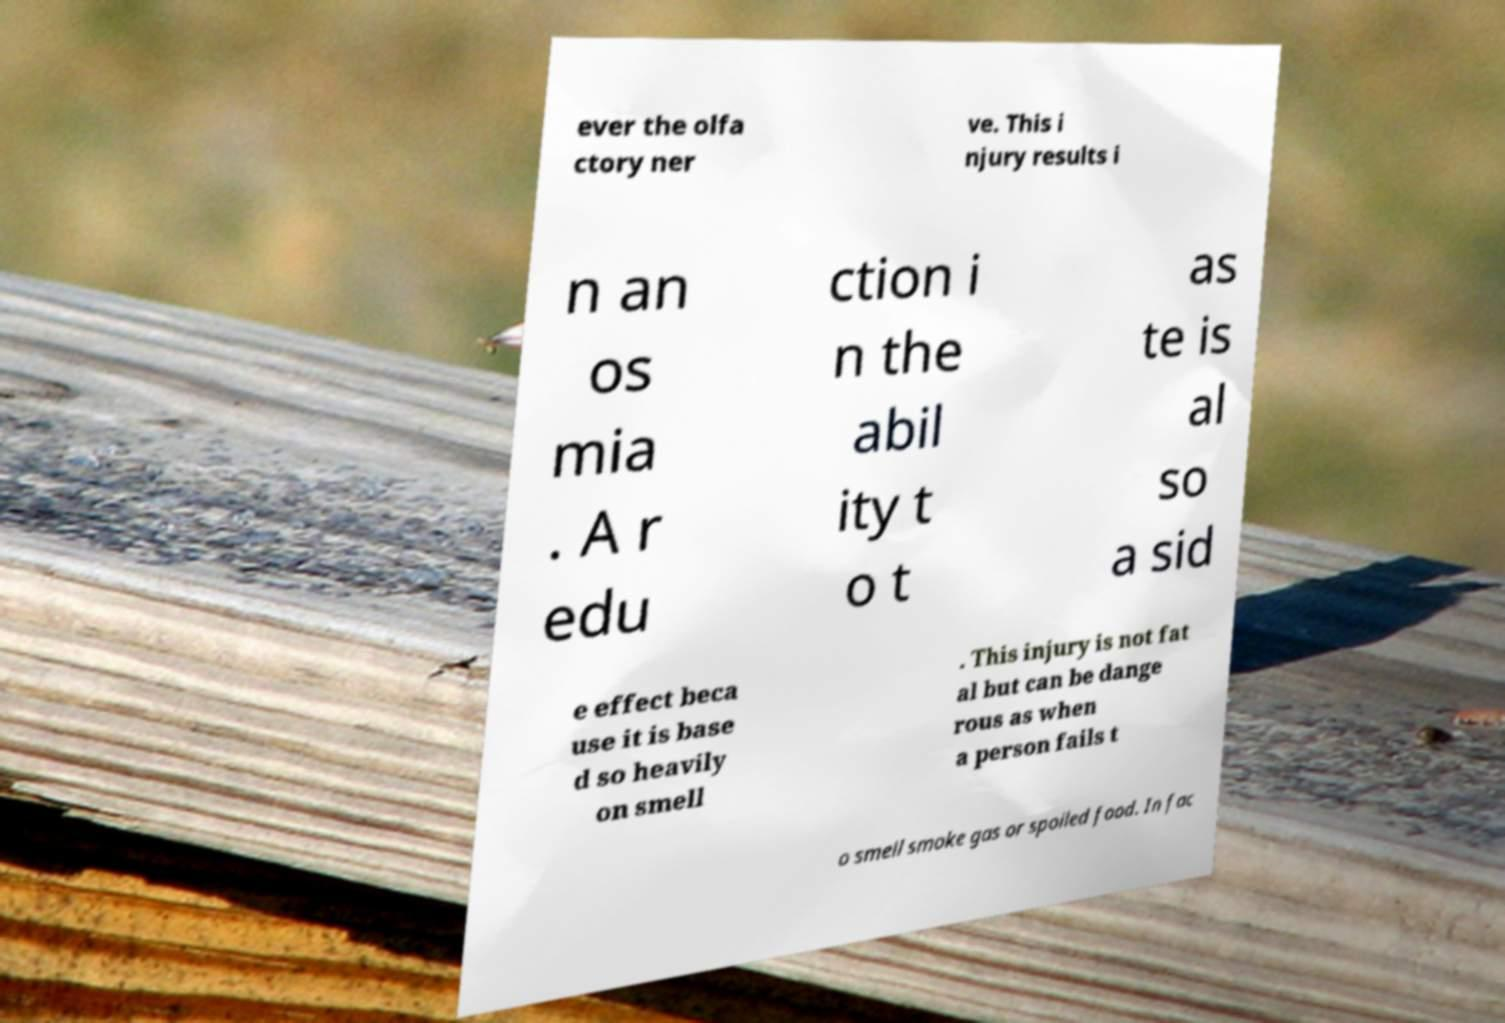Can you accurately transcribe the text from the provided image for me? ever the olfa ctory ner ve. This i njury results i n an os mia . A r edu ction i n the abil ity t o t as te is al so a sid e effect beca use it is base d so heavily on smell . This injury is not fat al but can be dange rous as when a person fails t o smell smoke gas or spoiled food. In fac 